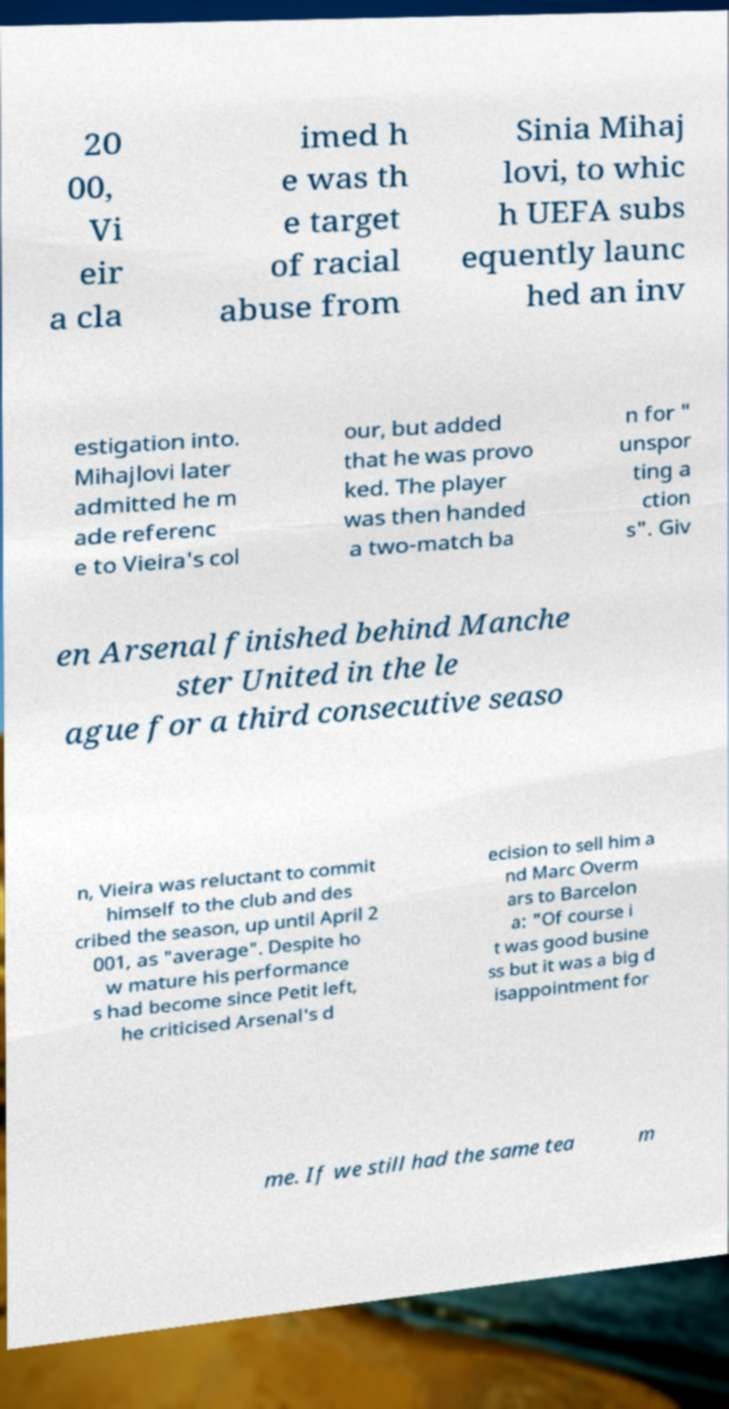Please identify and transcribe the text found in this image. 20 00, Vi eir a cla imed h e was th e target of racial abuse from Sinia Mihaj lovi, to whic h UEFA subs equently launc hed an inv estigation into. Mihajlovi later admitted he m ade referenc e to Vieira's col our, but added that he was provo ked. The player was then handed a two-match ba n for " unspor ting a ction s". Giv en Arsenal finished behind Manche ster United in the le ague for a third consecutive seaso n, Vieira was reluctant to commit himself to the club and des cribed the season, up until April 2 001, as "average". Despite ho w mature his performance s had become since Petit left, he criticised Arsenal's d ecision to sell him a nd Marc Overm ars to Barcelon a: "Of course i t was good busine ss but it was a big d isappointment for me. If we still had the same tea m 